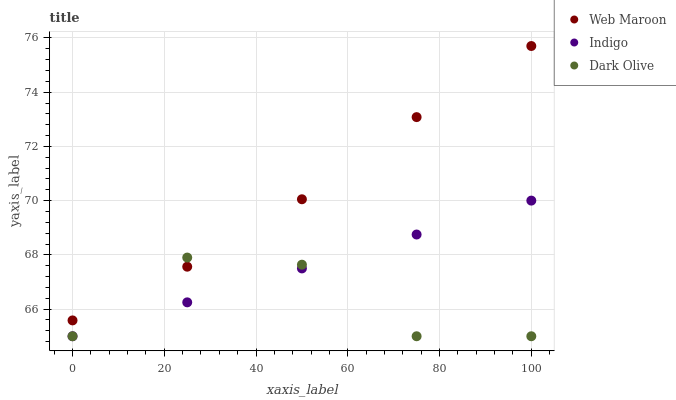Does Dark Olive have the minimum area under the curve?
Answer yes or no. Yes. Does Web Maroon have the maximum area under the curve?
Answer yes or no. Yes. Does Web Maroon have the minimum area under the curve?
Answer yes or no. No. Does Dark Olive have the maximum area under the curve?
Answer yes or no. No. Is Indigo the smoothest?
Answer yes or no. Yes. Is Dark Olive the roughest?
Answer yes or no. Yes. Is Web Maroon the smoothest?
Answer yes or no. No. Is Web Maroon the roughest?
Answer yes or no. No. Does Indigo have the lowest value?
Answer yes or no. Yes. Does Web Maroon have the lowest value?
Answer yes or no. No. Does Web Maroon have the highest value?
Answer yes or no. Yes. Does Dark Olive have the highest value?
Answer yes or no. No. Is Indigo less than Web Maroon?
Answer yes or no. Yes. Is Web Maroon greater than Indigo?
Answer yes or no. Yes. Does Dark Olive intersect Indigo?
Answer yes or no. Yes. Is Dark Olive less than Indigo?
Answer yes or no. No. Is Dark Olive greater than Indigo?
Answer yes or no. No. Does Indigo intersect Web Maroon?
Answer yes or no. No. 